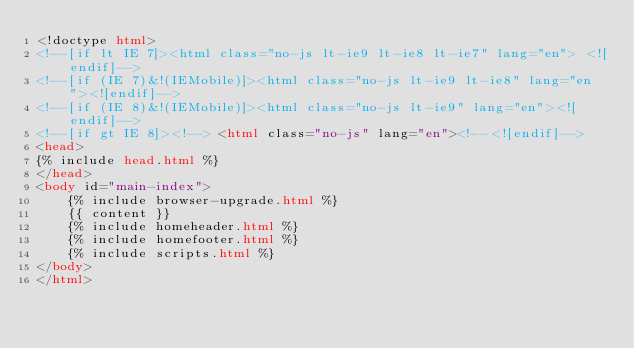Convert code to text. <code><loc_0><loc_0><loc_500><loc_500><_HTML_><!doctype html>
<!--[if lt IE 7]><html class="no-js lt-ie9 lt-ie8 lt-ie7" lang="en"> <![endif]-->
<!--[if (IE 7)&!(IEMobile)]><html class="no-js lt-ie9 lt-ie8" lang="en"><![endif]-->
<!--[if (IE 8)&!(IEMobile)]><html class="no-js lt-ie9" lang="en"><![endif]-->
<!--[if gt IE 8]><!--> <html class="no-js" lang="en"><!--<![endif]-->
<head>
{% include head.html %}
</head>
<body id="main-index">
	{% include browser-upgrade.html %}
	{{ content }}
	{% include homeheader.html %}
	{% include homefooter.html %}
	{% include scripts.html %}
</body>
</html>
</code> 